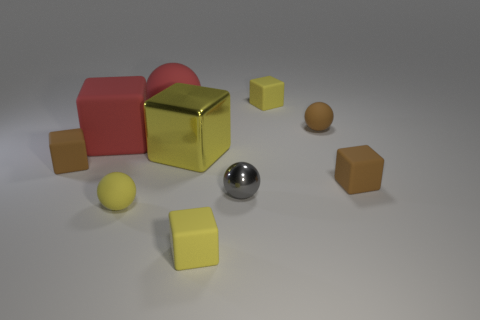Subtract all yellow cylinders. How many yellow cubes are left? 3 Subtract all tiny yellow spheres. How many spheres are left? 3 Subtract 2 spheres. How many spheres are left? 2 Subtract all yellow blocks. How many blocks are left? 3 Subtract all purple balls. Subtract all blue cylinders. How many balls are left? 4 Subtract all blocks. How many objects are left? 4 Subtract 0 cyan cubes. How many objects are left? 10 Subtract all tiny matte blocks. Subtract all small gray objects. How many objects are left? 5 Add 6 yellow shiny cubes. How many yellow shiny cubes are left? 7 Add 5 brown rubber spheres. How many brown rubber spheres exist? 6 